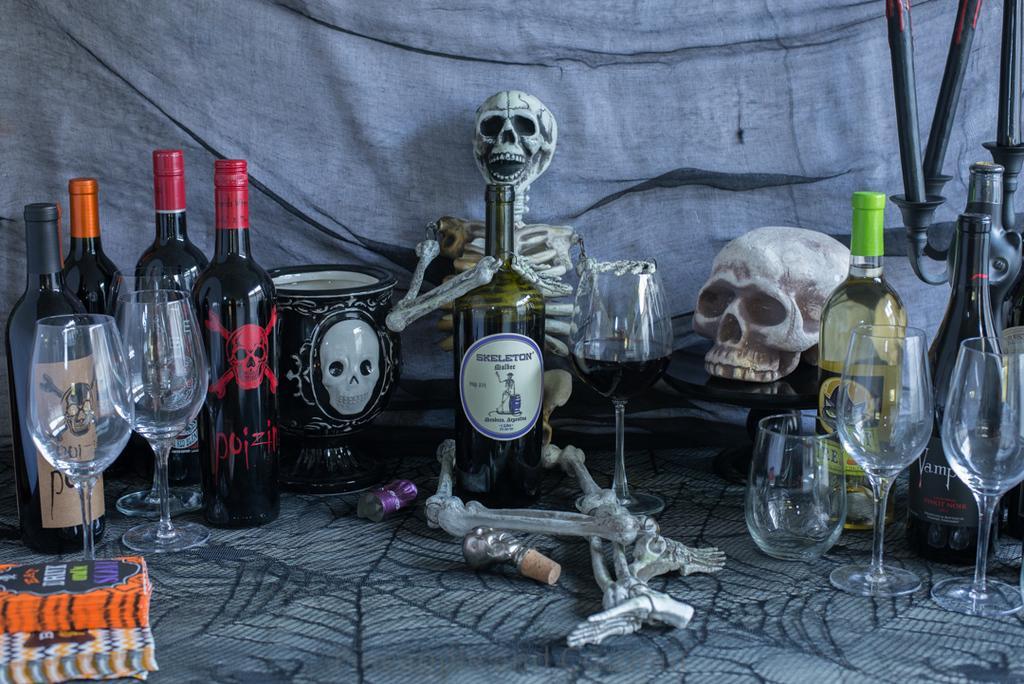How would you summarize this image in a sentence or two? There is a spider web cloth is on the table. And on the table there are bottles, glasses, book and a skeleton is kept. In the background there is a cloth. 